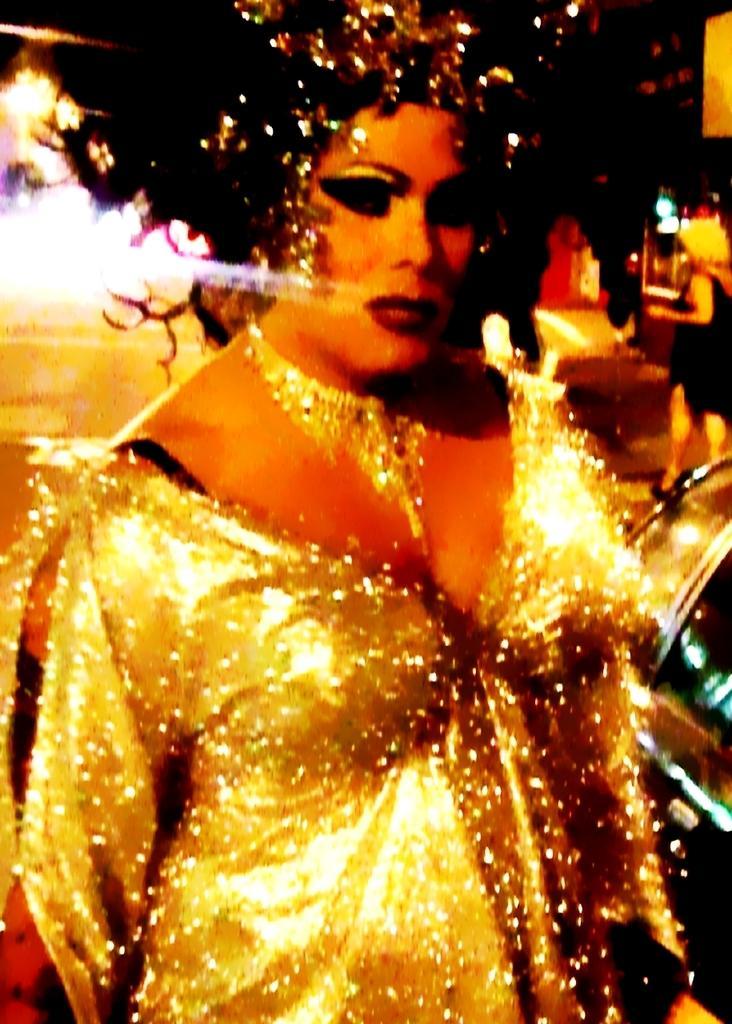Can you describe this image briefly? In this image in the center there is one woman who is standing, and in the background there is another woman and some lights. 